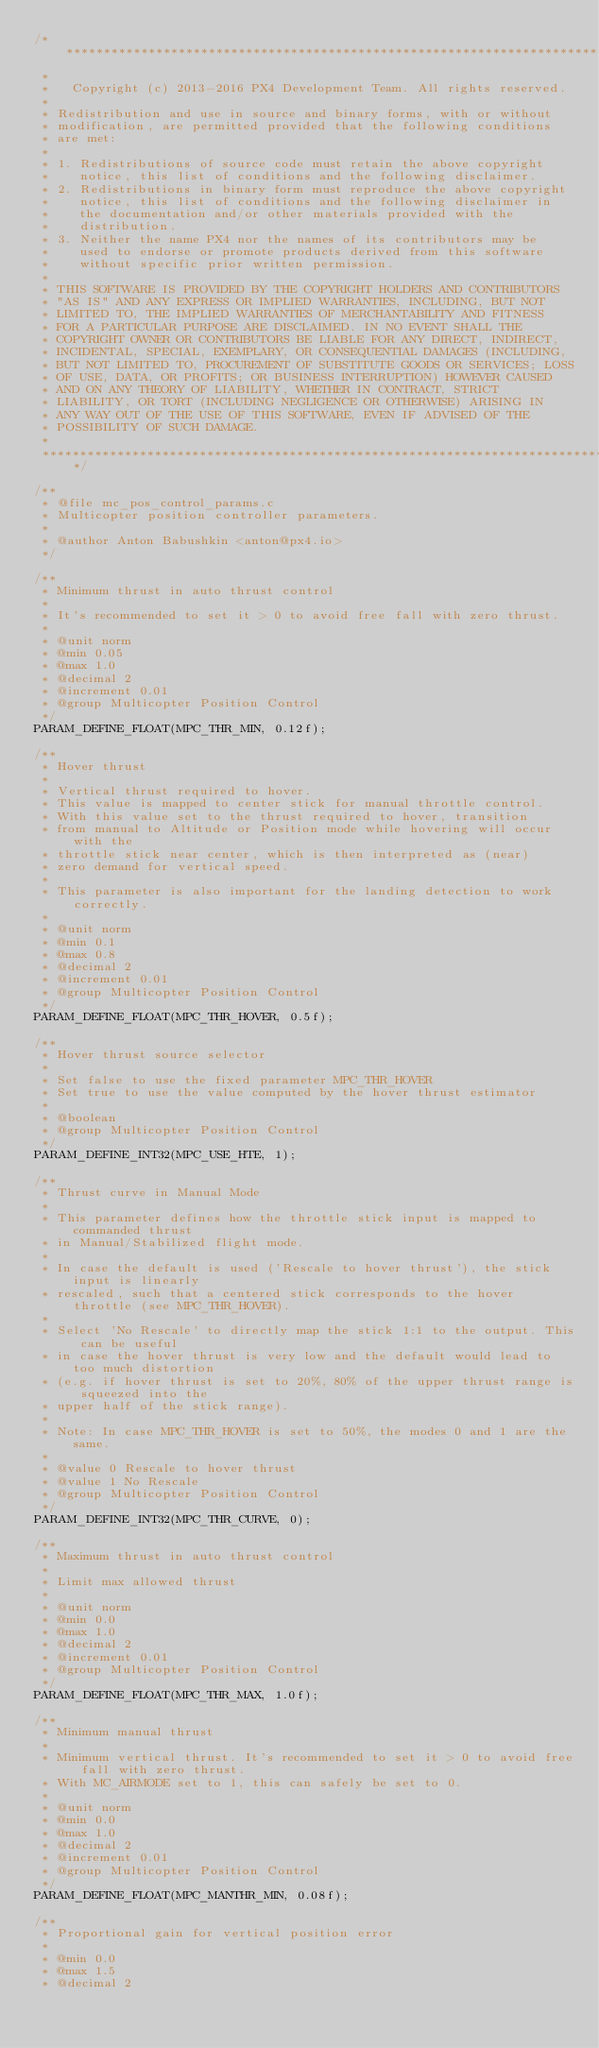<code> <loc_0><loc_0><loc_500><loc_500><_C_>/****************************************************************************
 *
 *   Copyright (c) 2013-2016 PX4 Development Team. All rights reserved.
 *
 * Redistribution and use in source and binary forms, with or without
 * modification, are permitted provided that the following conditions
 * are met:
 *
 * 1. Redistributions of source code must retain the above copyright
 *    notice, this list of conditions and the following disclaimer.
 * 2. Redistributions in binary form must reproduce the above copyright
 *    notice, this list of conditions and the following disclaimer in
 *    the documentation and/or other materials provided with the
 *    distribution.
 * 3. Neither the name PX4 nor the names of its contributors may be
 *    used to endorse or promote products derived from this software
 *    without specific prior written permission.
 *
 * THIS SOFTWARE IS PROVIDED BY THE COPYRIGHT HOLDERS AND CONTRIBUTORS
 * "AS IS" AND ANY EXPRESS OR IMPLIED WARRANTIES, INCLUDING, BUT NOT
 * LIMITED TO, THE IMPLIED WARRANTIES OF MERCHANTABILITY AND FITNESS
 * FOR A PARTICULAR PURPOSE ARE DISCLAIMED. IN NO EVENT SHALL THE
 * COPYRIGHT OWNER OR CONTRIBUTORS BE LIABLE FOR ANY DIRECT, INDIRECT,
 * INCIDENTAL, SPECIAL, EXEMPLARY, OR CONSEQUENTIAL DAMAGES (INCLUDING,
 * BUT NOT LIMITED TO, PROCUREMENT OF SUBSTITUTE GOODS OR SERVICES; LOSS
 * OF USE, DATA, OR PROFITS; OR BUSINESS INTERRUPTION) HOWEVER CAUSED
 * AND ON ANY THEORY OF LIABILITY, WHETHER IN CONTRACT, STRICT
 * LIABILITY, OR TORT (INCLUDING NEGLIGENCE OR OTHERWISE) ARISING IN
 * ANY WAY OUT OF THE USE OF THIS SOFTWARE, EVEN IF ADVISED OF THE
 * POSSIBILITY OF SUCH DAMAGE.
 *
 ****************************************************************************/

/**
 * @file mc_pos_control_params.c
 * Multicopter position controller parameters.
 *
 * @author Anton Babushkin <anton@px4.io>
 */

/**
 * Minimum thrust in auto thrust control
 *
 * It's recommended to set it > 0 to avoid free fall with zero thrust.
 *
 * @unit norm
 * @min 0.05
 * @max 1.0
 * @decimal 2
 * @increment 0.01
 * @group Multicopter Position Control
 */
PARAM_DEFINE_FLOAT(MPC_THR_MIN, 0.12f);

/**
 * Hover thrust
 *
 * Vertical thrust required to hover.
 * This value is mapped to center stick for manual throttle control.
 * With this value set to the thrust required to hover, transition
 * from manual to Altitude or Position mode while hovering will occur with the
 * throttle stick near center, which is then interpreted as (near)
 * zero demand for vertical speed.
 *
 * This parameter is also important for the landing detection to work correctly.
 *
 * @unit norm
 * @min 0.1
 * @max 0.8
 * @decimal 2
 * @increment 0.01
 * @group Multicopter Position Control
 */
PARAM_DEFINE_FLOAT(MPC_THR_HOVER, 0.5f);

/**
 * Hover thrust source selector
 *
 * Set false to use the fixed parameter MPC_THR_HOVER
 * Set true to use the value computed by the hover thrust estimator
 *
 * @boolean
 * @group Multicopter Position Control
 */
PARAM_DEFINE_INT32(MPC_USE_HTE, 1);

/**
 * Thrust curve in Manual Mode
 *
 * This parameter defines how the throttle stick input is mapped to commanded thrust
 * in Manual/Stabilized flight mode.
 *
 * In case the default is used ('Rescale to hover thrust'), the stick input is linearly
 * rescaled, such that a centered stick corresponds to the hover throttle (see MPC_THR_HOVER).
 *
 * Select 'No Rescale' to directly map the stick 1:1 to the output. This can be useful
 * in case the hover thrust is very low and the default would lead to too much distortion
 * (e.g. if hover thrust is set to 20%, 80% of the upper thrust range is squeezed into the
 * upper half of the stick range).
 *
 * Note: In case MPC_THR_HOVER is set to 50%, the modes 0 and 1 are the same.
 *
 * @value 0 Rescale to hover thrust
 * @value 1 No Rescale
 * @group Multicopter Position Control
 */
PARAM_DEFINE_INT32(MPC_THR_CURVE, 0);

/**
 * Maximum thrust in auto thrust control
 *
 * Limit max allowed thrust
 *
 * @unit norm
 * @min 0.0
 * @max 1.0
 * @decimal 2
 * @increment 0.01
 * @group Multicopter Position Control
 */
PARAM_DEFINE_FLOAT(MPC_THR_MAX, 1.0f);

/**
 * Minimum manual thrust
 *
 * Minimum vertical thrust. It's recommended to set it > 0 to avoid free fall with zero thrust.
 * With MC_AIRMODE set to 1, this can safely be set to 0.
 *
 * @unit norm
 * @min 0.0
 * @max 1.0
 * @decimal 2
 * @increment 0.01
 * @group Multicopter Position Control
 */
PARAM_DEFINE_FLOAT(MPC_MANTHR_MIN, 0.08f);

/**
 * Proportional gain for vertical position error
 *
 * @min 0.0
 * @max 1.5
 * @decimal 2</code> 